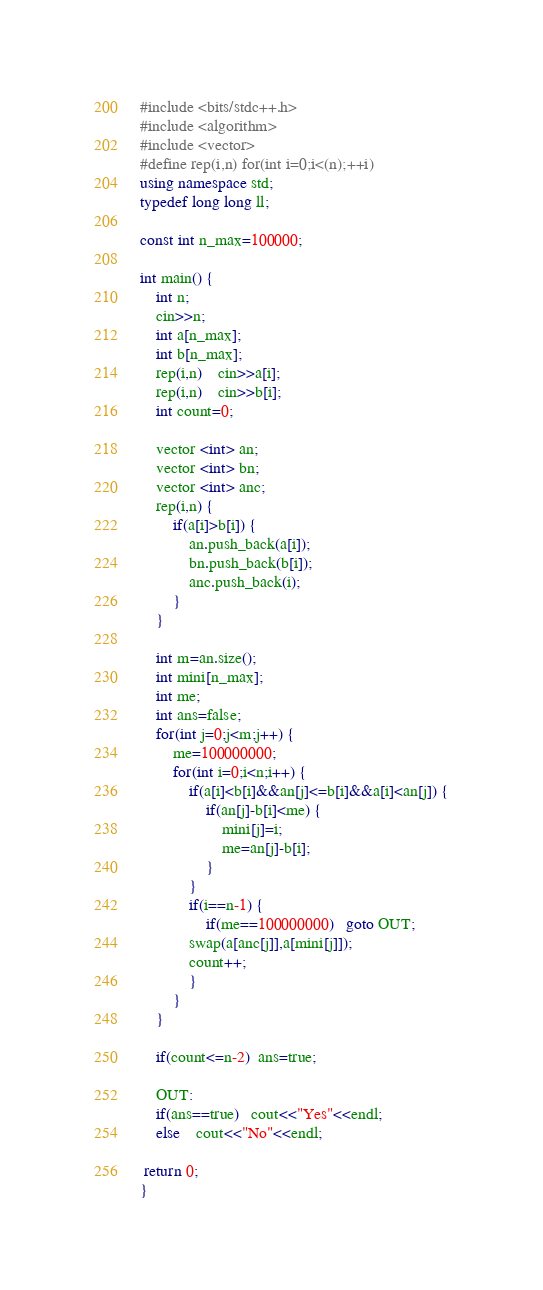Convert code to text. <code><loc_0><loc_0><loc_500><loc_500><_C++_>#include <bits/stdc++.h>
#include <algorithm>
#include <vector>
#define rep(i,n) for(int i=0;i<(n);++i)
using namespace std;
typedef long long ll;

const int n_max=100000;
 
int main() {
    int n;
    cin>>n;
    int a[n_max];
    int b[n_max];
    rep(i,n)    cin>>a[i];
    rep(i,n)    cin>>b[i];
    int count=0;
    
    vector <int> an;
    vector <int> bn;
    vector <int> anc;
    rep(i,n) {
        if(a[i]>b[i]) {
            an.push_back(a[i]);
            bn.push_back(b[i]);
            anc.push_back(i);
        }
    }

    int m=an.size();
    int mini[n_max];
    int me;
    int ans=false;
    for(int j=0;j<m;j++) {
        me=100000000;
        for(int i=0;i<n;i++) {
            if(a[i]<b[i]&&an[j]<=b[i]&&a[i]<an[j]) {
                if(an[j]-b[i]<me) {
                    mini[j]=i;
                    me=an[j]-b[i];
                }
            }
            if(i==n-1) {
                if(me==100000000)   goto OUT;
            swap(a[anc[j]],a[mini[j]]);
            count++;
            }
        }
    }

    if(count<=n-2)  ans=true;
       
    OUT:
    if(ans==true)   cout<<"Yes"<<endl;
    else    cout<<"No"<<endl;
      
 return 0;
}</code> 